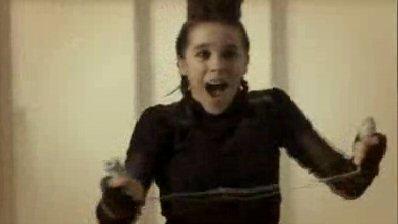Is this photo indoors?
Answer briefly. Yes. What is the girl holding?
Write a very short answer. String. What is the color of the wall?
Quick response, please. White. 